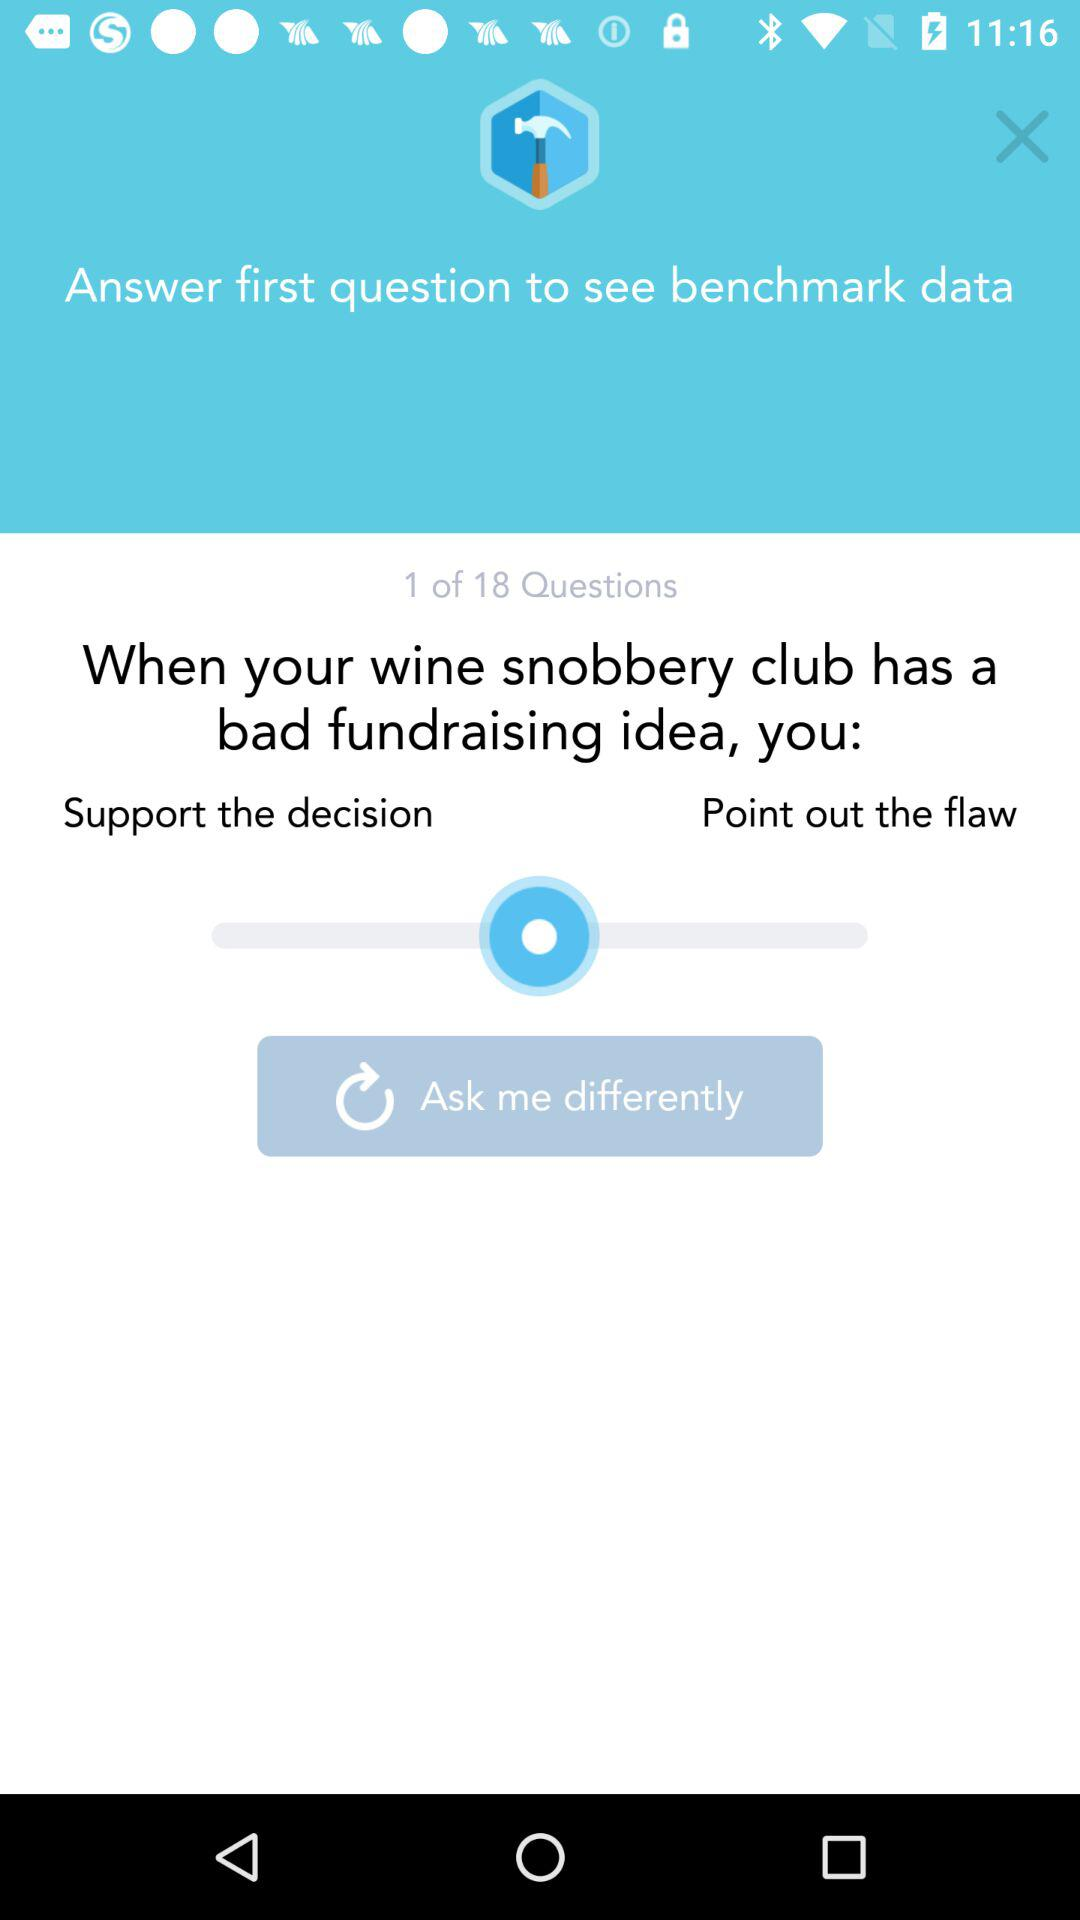How many options are there for what to do when your wine snobbery club has a bad fundraising idea?
Answer the question using a single word or phrase. 2 